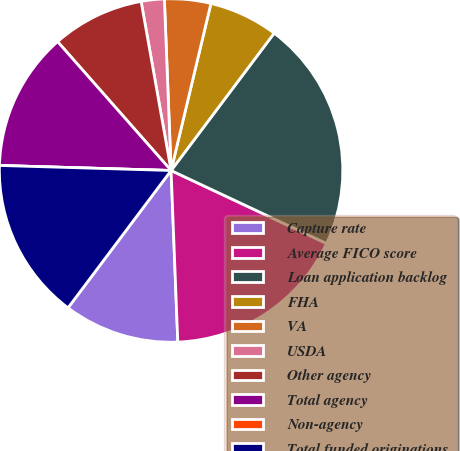Convert chart to OTSL. <chart><loc_0><loc_0><loc_500><loc_500><pie_chart><fcel>Capture rate<fcel>Average FICO score<fcel>Loan application backlog<fcel>FHA<fcel>VA<fcel>USDA<fcel>Other agency<fcel>Total agency<fcel>Non-agency<fcel>Total funded originations<nl><fcel>10.87%<fcel>17.39%<fcel>21.74%<fcel>6.52%<fcel>4.35%<fcel>2.17%<fcel>8.7%<fcel>13.04%<fcel>0.0%<fcel>15.22%<nl></chart> 